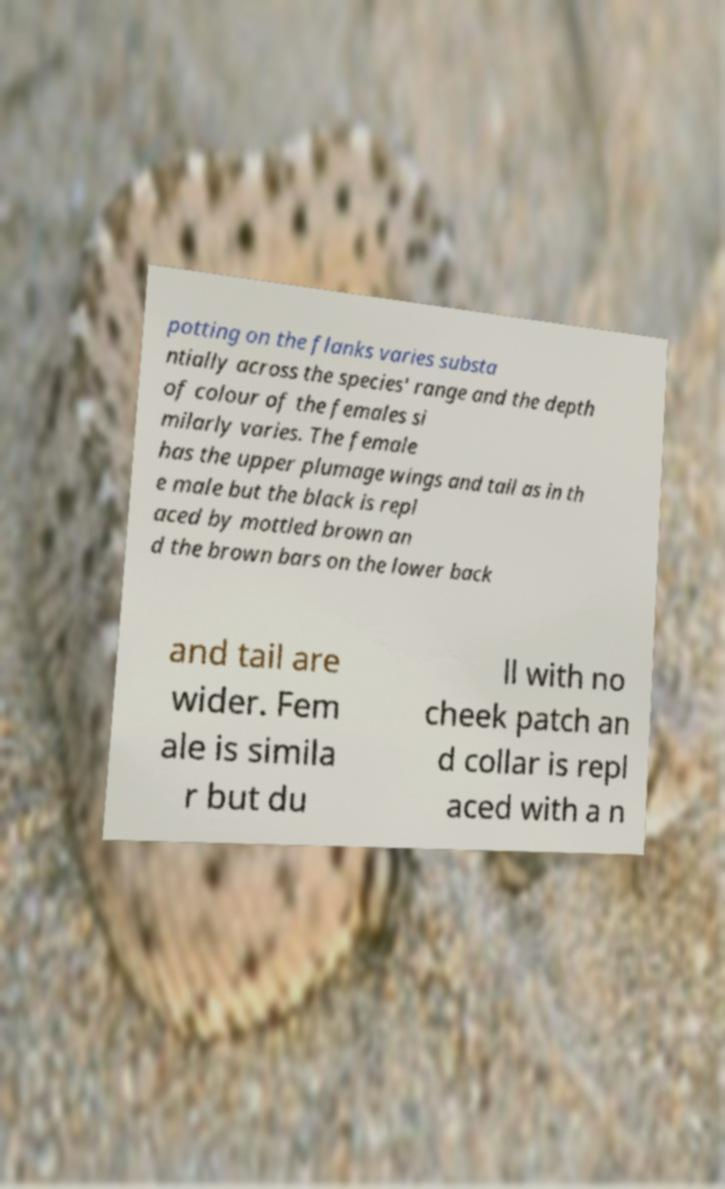Could you assist in decoding the text presented in this image and type it out clearly? potting on the flanks varies substa ntially across the species' range and the depth of colour of the females si milarly varies. The female has the upper plumage wings and tail as in th e male but the black is repl aced by mottled brown an d the brown bars on the lower back and tail are wider. Fem ale is simila r but du ll with no cheek patch an d collar is repl aced with a n 